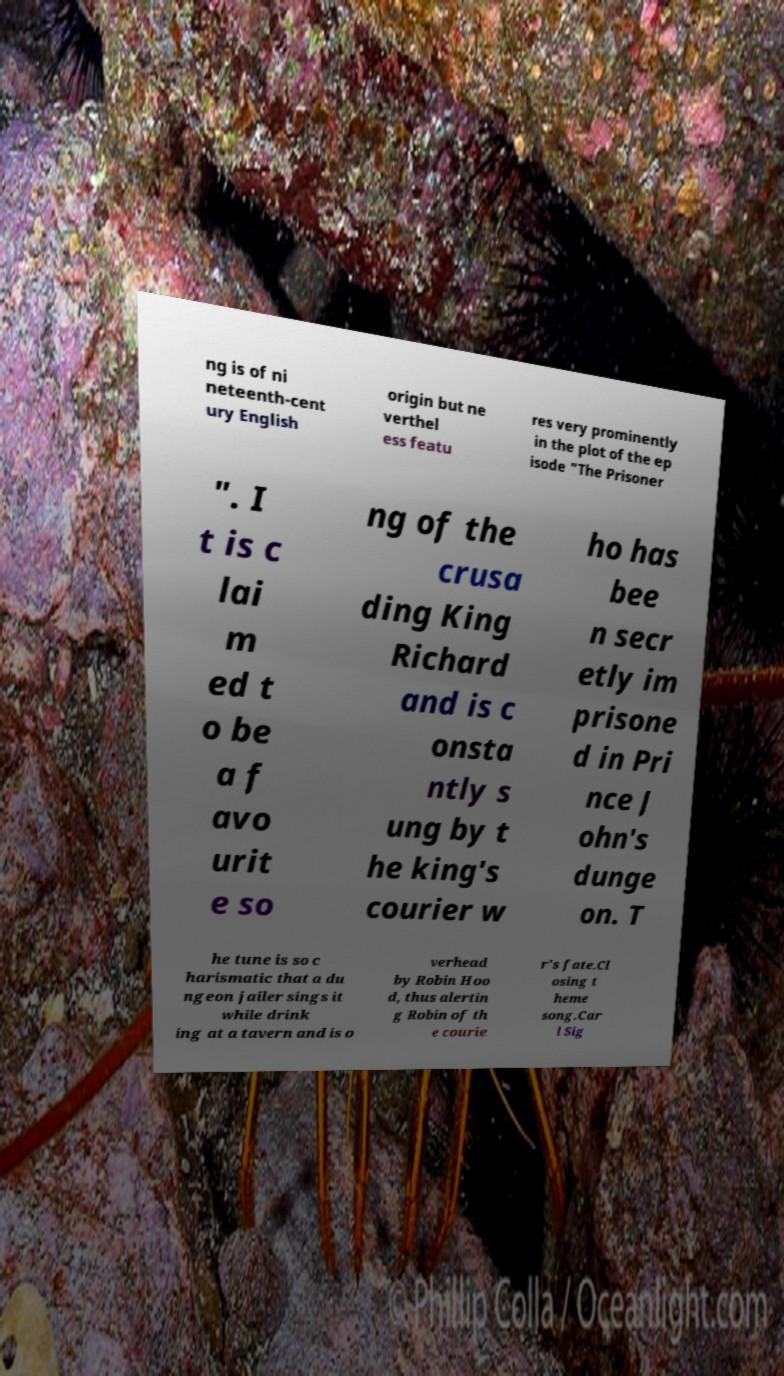Can you read and provide the text displayed in the image?This photo seems to have some interesting text. Can you extract and type it out for me? ng is of ni neteenth-cent ury English origin but ne verthel ess featu res very prominently in the plot of the ep isode "The Prisoner ". I t is c lai m ed t o be a f avo urit e so ng of the crusa ding King Richard and is c onsta ntly s ung by t he king's courier w ho has bee n secr etly im prisone d in Pri nce J ohn's dunge on. T he tune is so c harismatic that a du ngeon jailer sings it while drink ing at a tavern and is o verhead by Robin Hoo d, thus alertin g Robin of th e courie r's fate.Cl osing t heme song.Car l Sig 